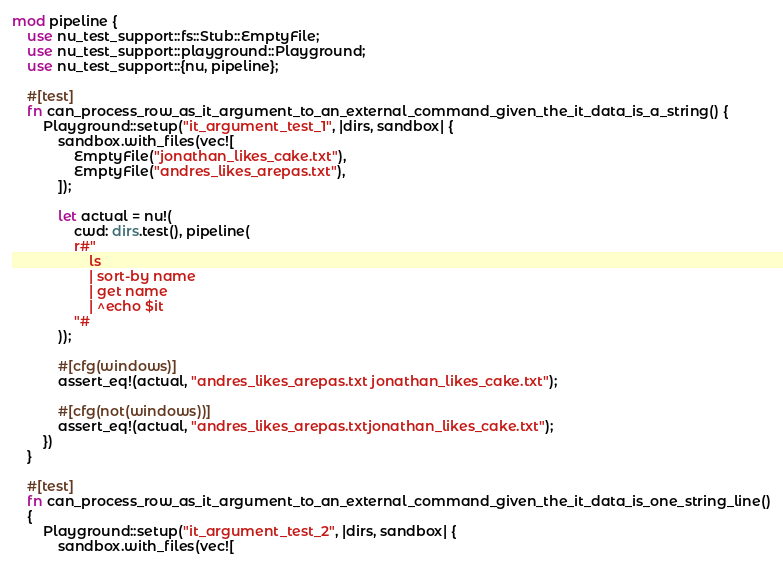Convert code to text. <code><loc_0><loc_0><loc_500><loc_500><_Rust_>mod pipeline {
    use nu_test_support::fs::Stub::EmptyFile;
    use nu_test_support::playground::Playground;
    use nu_test_support::{nu, pipeline};

    #[test]
    fn can_process_row_as_it_argument_to_an_external_command_given_the_it_data_is_a_string() {
        Playground::setup("it_argument_test_1", |dirs, sandbox| {
            sandbox.with_files(vec![
                EmptyFile("jonathan_likes_cake.txt"),
                EmptyFile("andres_likes_arepas.txt"),
            ]);

            let actual = nu!(
                cwd: dirs.test(), pipeline(
                r#"
                    ls
                    | sort-by name
                    | get name
                    | ^echo $it
                "#
            ));

            #[cfg(windows)]
            assert_eq!(actual, "andres_likes_arepas.txt jonathan_likes_cake.txt");

            #[cfg(not(windows))]
            assert_eq!(actual, "andres_likes_arepas.txtjonathan_likes_cake.txt");
        })
    }

    #[test]
    fn can_process_row_as_it_argument_to_an_external_command_given_the_it_data_is_one_string_line()
    {
        Playground::setup("it_argument_test_2", |dirs, sandbox| {
            sandbox.with_files(vec![</code> 